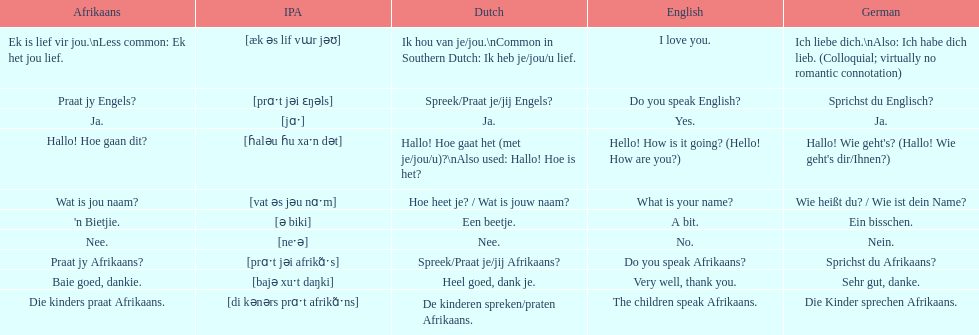Parse the table in full. {'header': ['Afrikaans', 'IPA', 'Dutch', 'English', 'German'], 'rows': [['Ek is lief vir jou.\\nLess common: Ek het jou lief.', '[æk əs lif vɯr jəʊ]', 'Ik hou van je/jou.\\nCommon in Southern Dutch: Ik heb je/jou/u lief.', 'I love you.', 'Ich liebe dich.\\nAlso: Ich habe dich lieb. (Colloquial; virtually no romantic connotation)'], ['Praat jy Engels?', '[prɑˑt jəi ɛŋəls]', 'Spreek/Praat je/jij Engels?', 'Do you speak English?', 'Sprichst du Englisch?'], ['Ja.', '[jɑˑ]', 'Ja.', 'Yes.', 'Ja.'], ['Hallo! Hoe gaan dit?', '[ɦaləu ɦu xaˑn dət]', 'Hallo! Hoe gaat het (met je/jou/u)?\\nAlso used: Hallo! Hoe is het?', 'Hello! How is it going? (Hello! How are you?)', "Hallo! Wie geht's? (Hallo! Wie geht's dir/Ihnen?)"], ['Wat is jou naam?', '[vat əs jəu nɑˑm]', 'Hoe heet je? / Wat is jouw naam?', 'What is your name?', 'Wie heißt du? / Wie ist dein Name?'], ["'n Bietjie.", '[ə biki]', 'Een beetje.', 'A bit.', 'Ein bisschen.'], ['Nee.', '[neˑə]', 'Nee.', 'No.', 'Nein.'], ['Praat jy Afrikaans?', '[prɑˑt jəi afrikɑ̃ˑs]', 'Spreek/Praat je/jij Afrikaans?', 'Do you speak Afrikaans?', 'Sprichst du Afrikaans?'], ['Baie goed, dankie.', '[bajə xuˑt daŋki]', 'Heel goed, dank je.', 'Very well, thank you.', 'Sehr gut, danke.'], ['Die kinders praat Afrikaans.', '[di kənərs prɑˑt afrikɑ̃ˑns]', 'De kinderen spreken/praten Afrikaans.', 'The children speak Afrikaans.', 'Die Kinder sprechen Afrikaans.']]} How do you say 'i love you' in afrikaans? Ek is lief vir jou. 